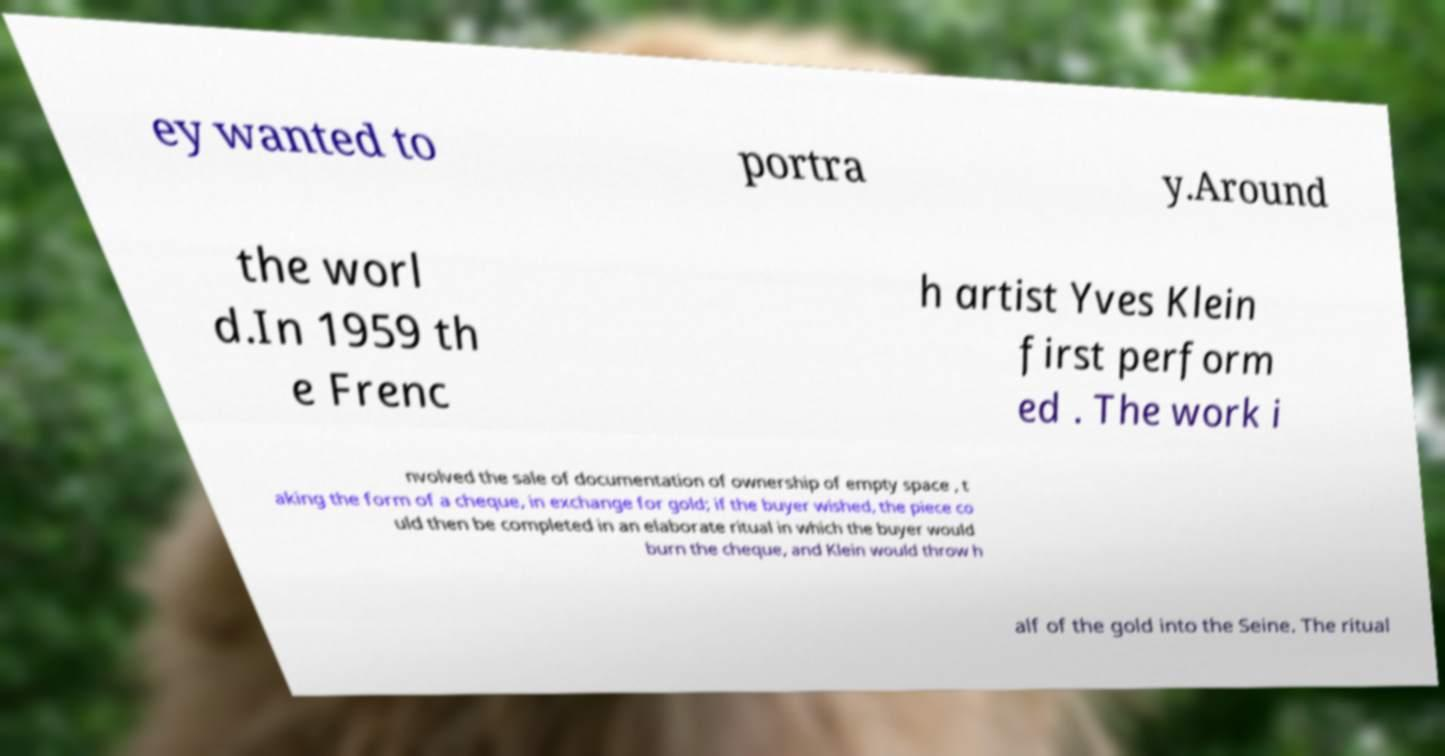There's text embedded in this image that I need extracted. Can you transcribe it verbatim? ey wanted to portra y.Around the worl d.In 1959 th e Frenc h artist Yves Klein first perform ed . The work i nvolved the sale of documentation of ownership of empty space , t aking the form of a cheque, in exchange for gold; if the buyer wished, the piece co uld then be completed in an elaborate ritual in which the buyer would burn the cheque, and Klein would throw h alf of the gold into the Seine. The ritual 